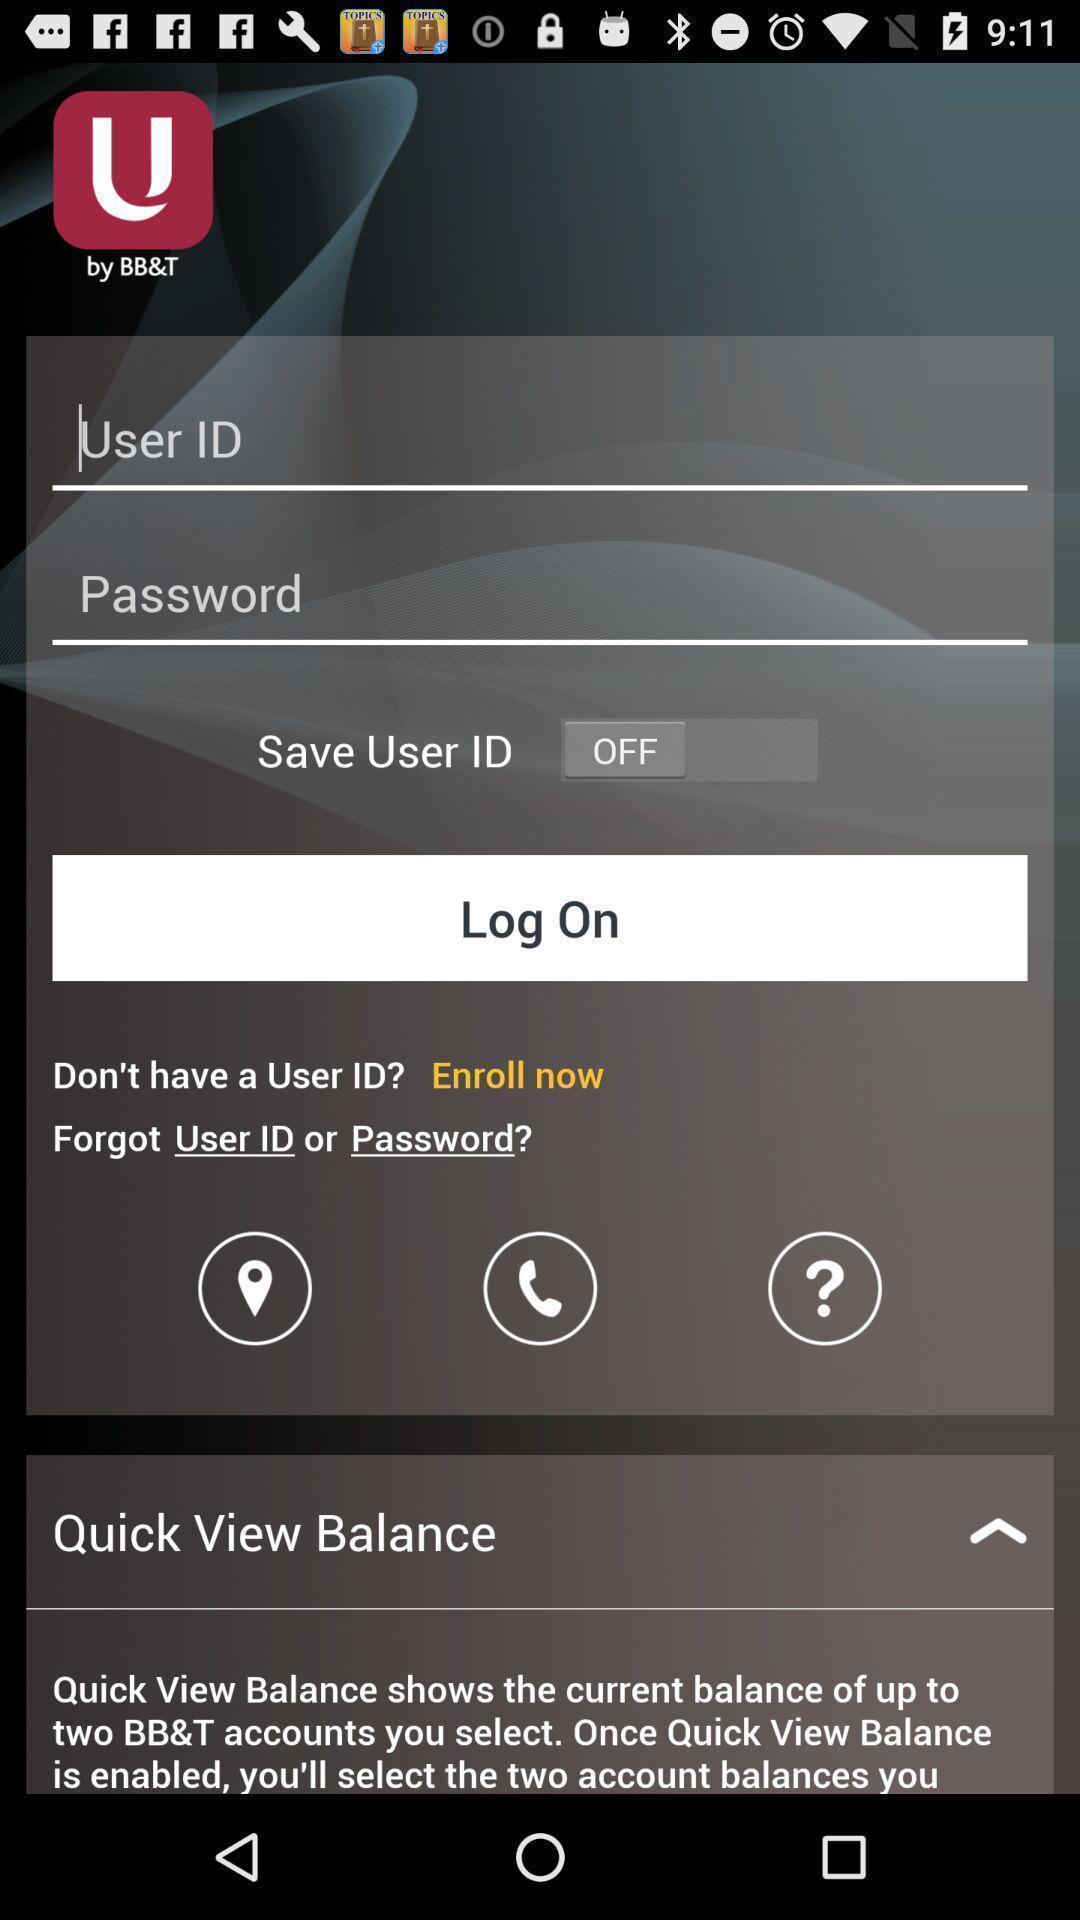Please provide a description for this image. Login page. 